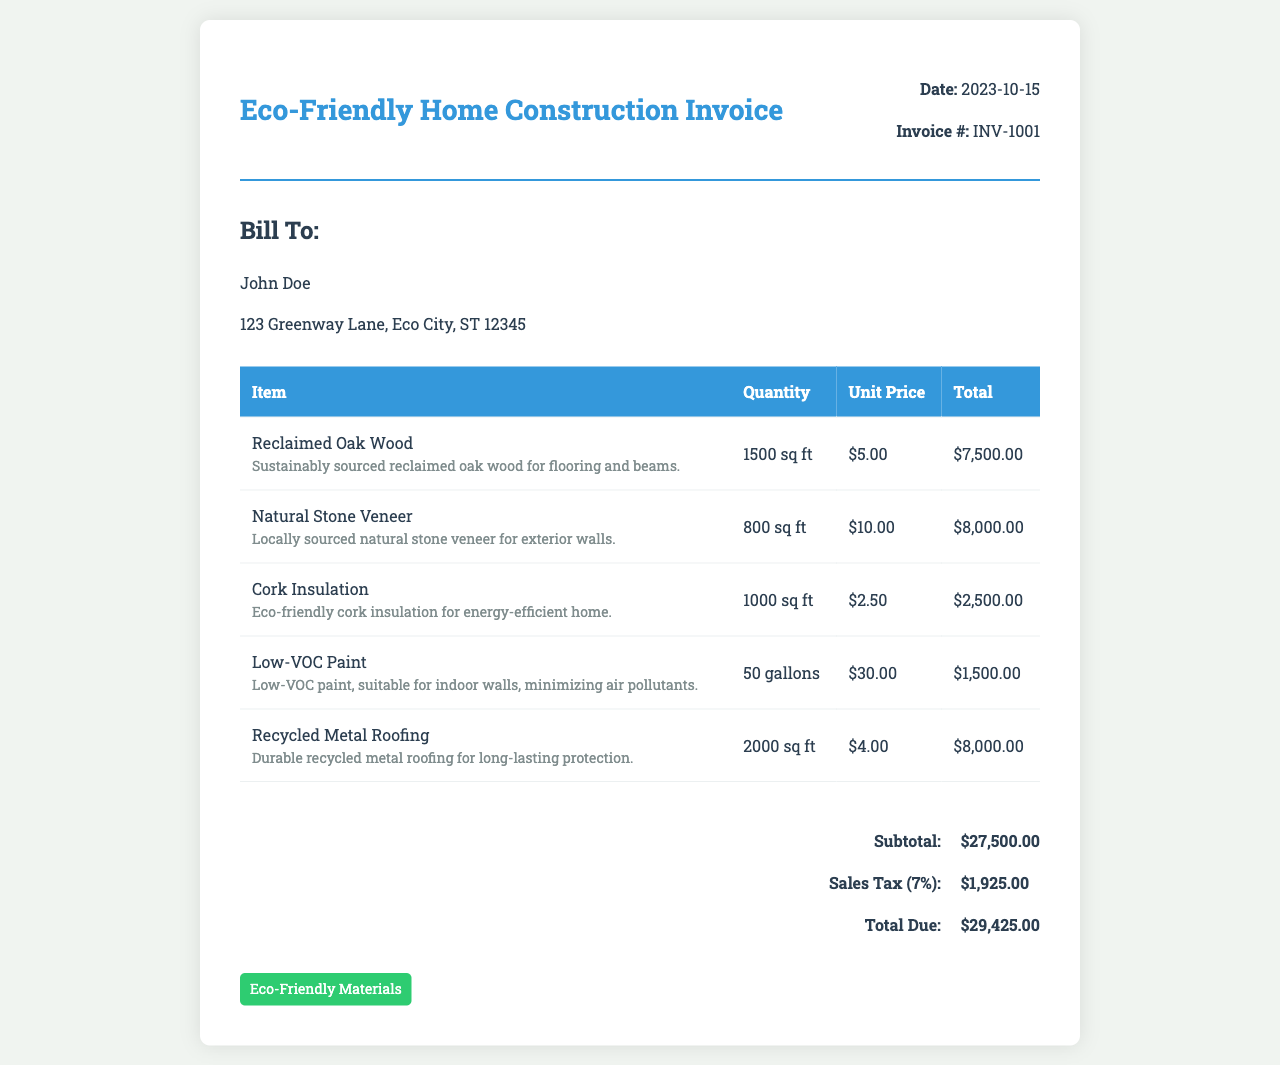What is the invoice date? The invoice date is mentioned in the invoice details section.
Answer: 2023-10-15 Who is the invoice billed to? The invoice clearly indicates the name of the person being billed.
Answer: John Doe What is the total due amount? The total due amount is calculated at the end of the invoice.
Answer: $29,425.00 How much was spent on Reclaimed Oak Wood? The total for Reclaimed Oak Wood is provided in the invoice table.
Answer: $7,500.00 What percentage is the sales tax? The document specifies the sales tax percentage.
Answer: 7% What is the quantity of Natural Stone Veneer purchased? The quantity of Natural Stone Veneer is listed in the item details.
Answer: 800 sq ft Which material is used for insulation? The item description mentions the material used distinctly.
Answer: Cork Insulation What type of badge is displayed at the bottom? The badge indicates a specific characteristic of the materials in the invoice.
Answer: Eco-Friendly Materials How many gallons of Low-VOC Paint were purchased? The quantity of Low-VOC Paint is stated in the item table.
Answer: 50 gallons 